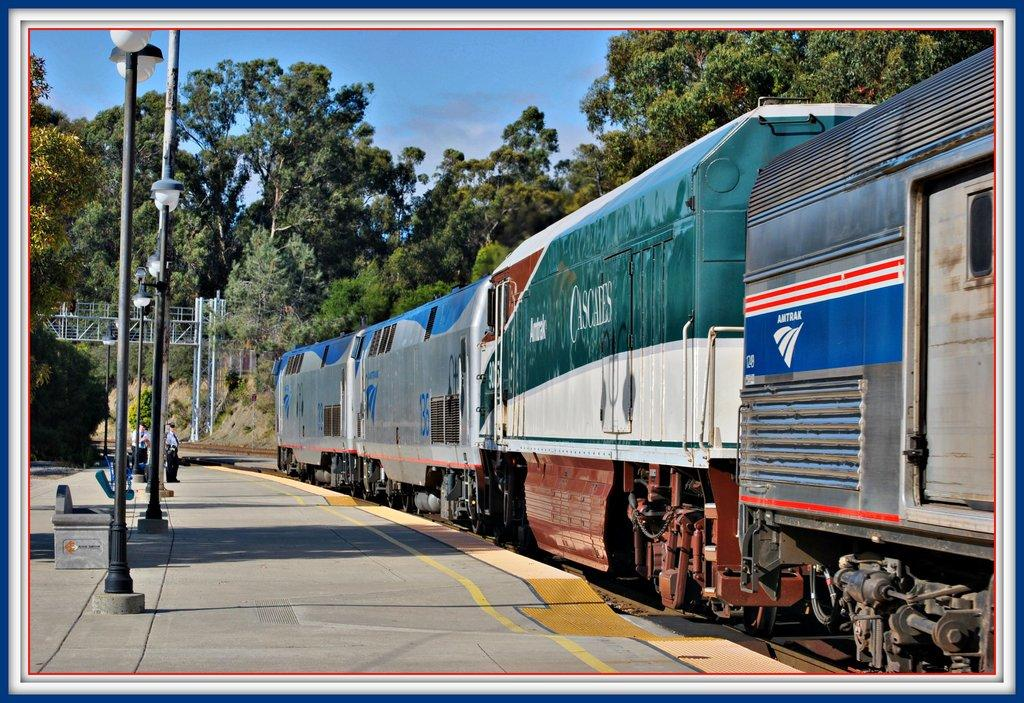What can be seen in the sky in the image? The sky is visible in the image, but no specific details about the sky can be determined from the provided facts. What type of vegetation is present in the image? There are trees in the image. What type of transportation infrastructure is present in the image? There is a railway station and railway tracks in the image. What other structures can be seen in the image? There are poles, lights, and benches in the image. What mode of transportation is present in the image? There is a train in the image. What type of pipe is visible in the image? There is no pipe present in the image. What type of branch is holding the train in the image? There is no branch holding the train in the image; the train is on the railway tracks. 